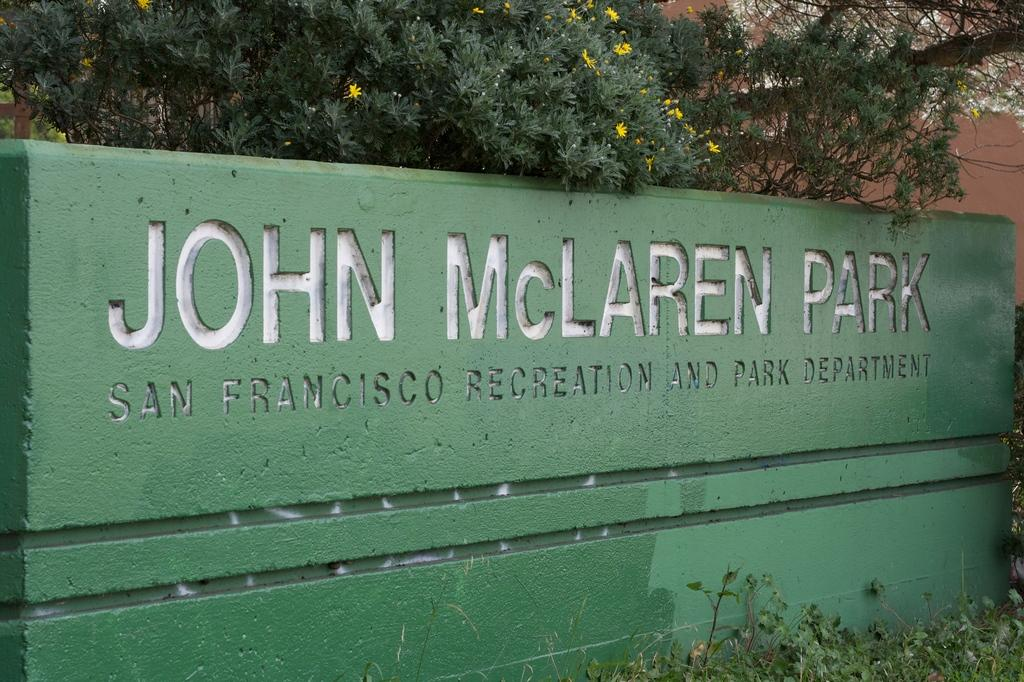What is the main object in the image? There is a board in the image. What else can be seen in the image besides the board? There are plants in the image. What can be seen in the background of the image? There are trees, flowers, and a wall in the background of the image. How many bananas are hanging from the trees in the background of the image? There are no bananas visible in the image; only trees, flowers, and a wall can be seen in the background. Are there any rabbits present in the image? There are no rabbits present in the image; only a board, plants, trees, flowers, and a wall are visible. 